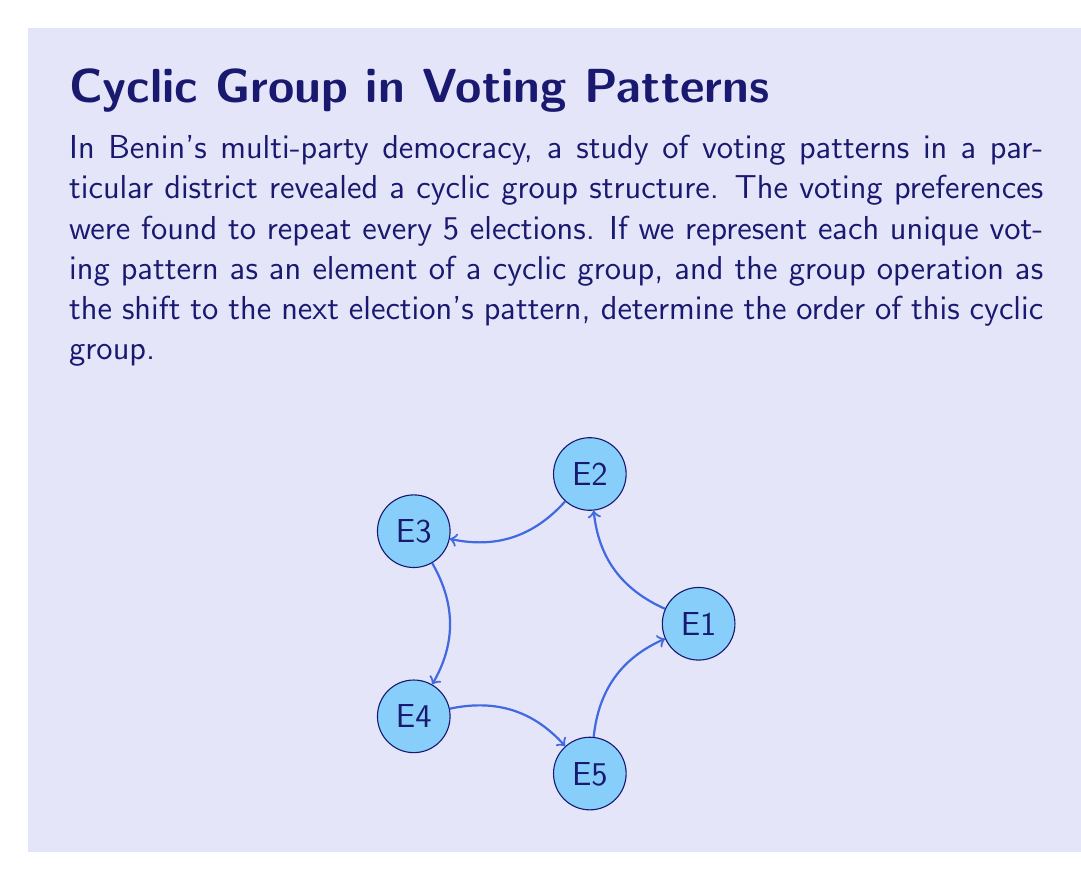Give your solution to this math problem. To determine the order of this cyclic group, we need to understand the following concepts:

1) In a cyclic group, the order of the group is equal to the number of unique elements generated by repeatedly applying the group operation to any non-identity element.

2) In this case, each unique voting pattern represents an element of the group, and the group operation shifts to the next election's pattern.

3) We are told that the voting patterns repeat every 5 elections. This means that after applying the group operation 5 times, we return to the original pattern.

4) Mathematically, if we denote the generator of this group as $a$, we have:

   $a^5 = e$ (where $e$ is the identity element)

5) This implies that the smallest positive integer $n$ for which $a^n = e$ is 5.

6) By the definition of a cyclic group, the order of the group is equal to this smallest positive integer $n$.

Therefore, the order of this cyclic group is 5.

In ring theory terms, this group is isomorphic to $\mathbb{Z}/5\mathbb{Z}$, the integers modulo 5 under addition.
Answer: 5 